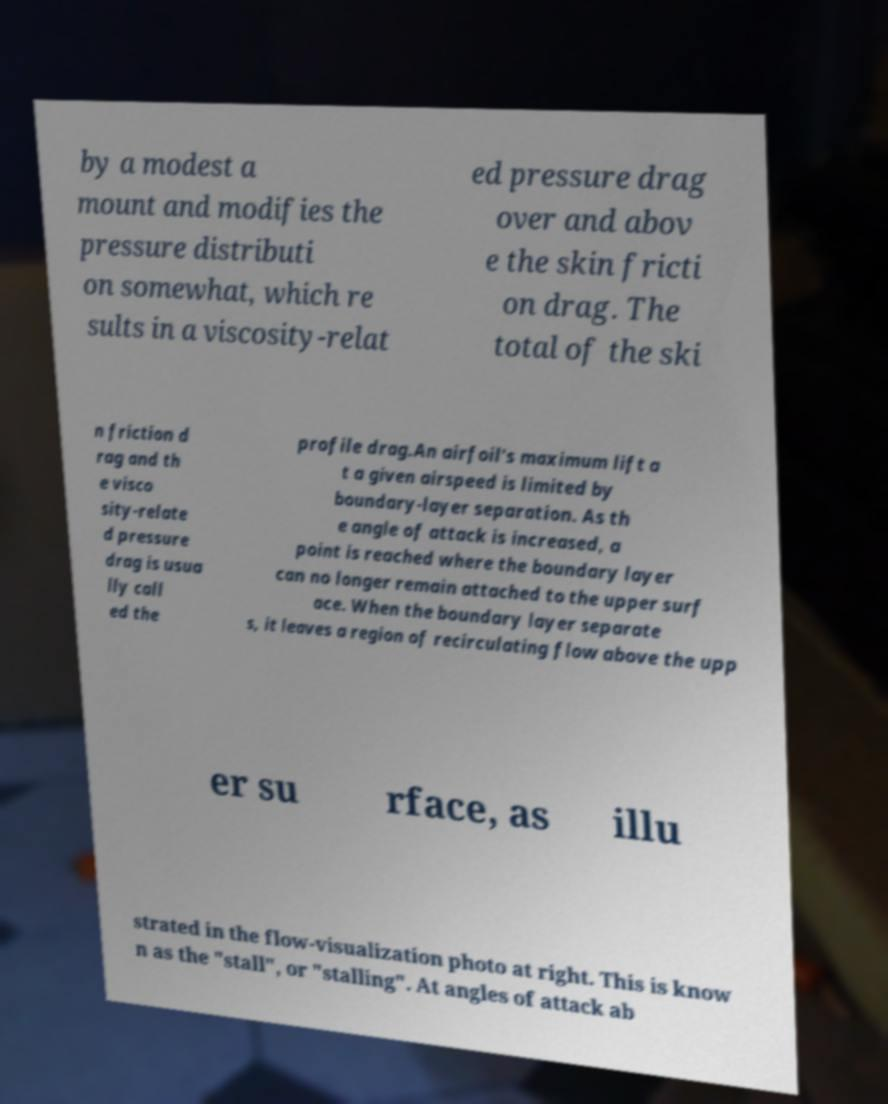Could you assist in decoding the text presented in this image and type it out clearly? by a modest a mount and modifies the pressure distributi on somewhat, which re sults in a viscosity-relat ed pressure drag over and abov e the skin fricti on drag. The total of the ski n friction d rag and th e visco sity-relate d pressure drag is usua lly call ed the profile drag.An airfoil's maximum lift a t a given airspeed is limited by boundary-layer separation. As th e angle of attack is increased, a point is reached where the boundary layer can no longer remain attached to the upper surf ace. When the boundary layer separate s, it leaves a region of recirculating flow above the upp er su rface, as illu strated in the flow-visualization photo at right. This is know n as the "stall", or "stalling". At angles of attack ab 